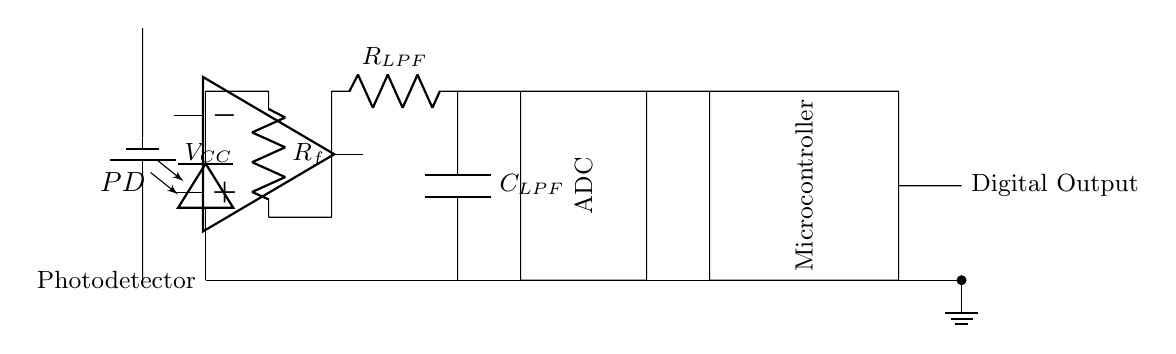What type of sensor is used in this circuit? The circuit diagram shows a photodiode labeled as PD, indicating that the sensor used for light detection is a photodiode.
Answer: Photodiode What is the role of the operational amplifier in this circuit? The operational amplifier (op amp) functions as a transimpedance amplifier, converting the photocurrent from the photodiode into a voltage signal for further processing.
Answer: Transimpedance amplifier What components make up the low-pass filter? The low-pass filter consists of a resistor labeled as R with the subscript LPF and a capacitor labeled as C with the subscript LPF, working together to filter out high-frequency noise.
Answer: Resistor and capacitor How many microcontrollers are present in this diagram? The circuit diagram includes a single microcontroller that processes the digital output from the preceding analog circuitry.
Answer: One What is the purpose of the ADC in this circuit? The ADC (Analog-to-Digital Converter) converts the analog voltage output from the low-pass filter into a digital signal, which can be processed by the microcontroller.
Answer: Convert analog to digital What type of voltage source is represented in this circuit? The circuit diagram shows a battery component, which serves as the voltage source providing power to the circuit.
Answer: Battery What is the connection type for the output from the microcontroller? The output from the microcontroller is connected via a short (indicating a direct connection) to the digital output labeled in the circuit.
Answer: Short 